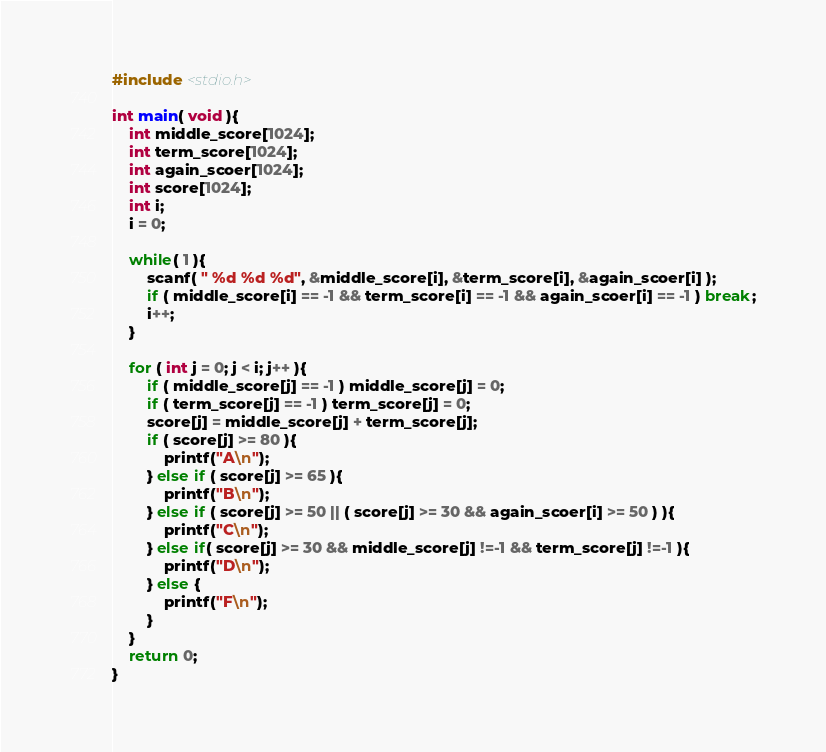Convert code to text. <code><loc_0><loc_0><loc_500><loc_500><_C_>#include <stdio.h>

int main( void ){
    int middle_score[1024];
    int term_score[1024];
    int again_scoer[1024];
    int score[1024];
    int i;
    i = 0;

    while( 1 ){
        scanf( " %d %d %d", &middle_score[i], &term_score[i], &again_scoer[i] );
        if ( middle_score[i] == -1 && term_score[i] == -1 && again_scoer[i] == -1 ) break;
        i++;
    }

    for ( int j = 0; j < i; j++ ){
        if ( middle_score[j] == -1 ) middle_score[j] = 0;
        if ( term_score[j] == -1 ) term_score[j] = 0;
        score[j] = middle_score[j] + term_score[j];
        if ( score[j] >= 80 ){
            printf("A\n");
        } else if ( score[j] >= 65 ){
            printf("B\n");
        } else if ( score[j] >= 50 || ( score[j] >= 30 && again_scoer[i] >= 50 ) ){
            printf("C\n");
        } else if( score[j] >= 30 && middle_score[j] !=-1 && term_score[j] !=-1 ){
            printf("D\n");
        } else {
            printf("F\n");
        }
    }
    return 0;
}
</code> 